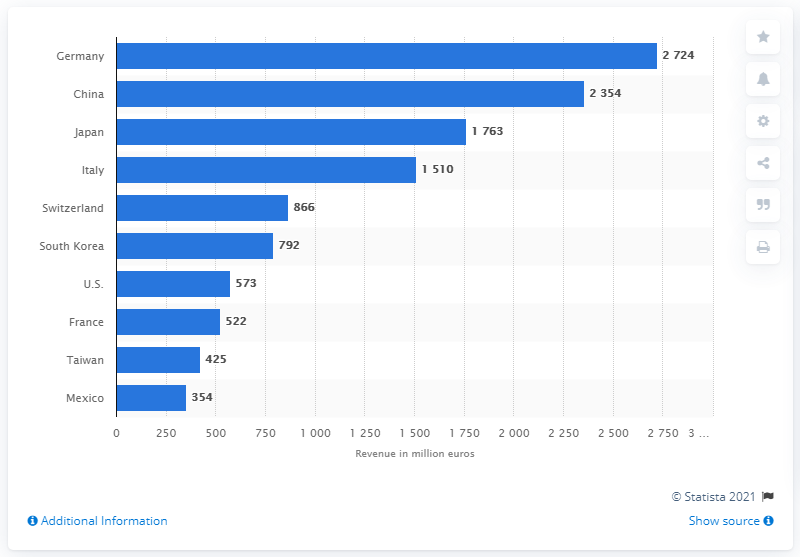Give some essential details in this illustration. In 2014, the value of textile machinery exported to the United States was 573 million dollars. 